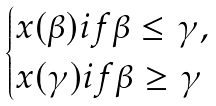<formula> <loc_0><loc_0><loc_500><loc_500>\begin{cases} x ( \beta ) i f \beta \leq \gamma , \\ x ( \gamma ) i f \beta \geq \gamma \end{cases}</formula> 